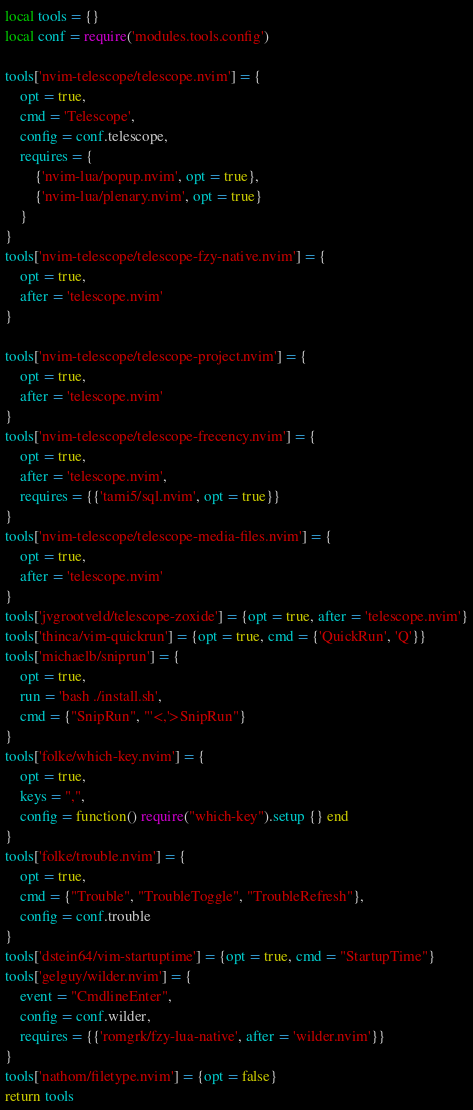<code> <loc_0><loc_0><loc_500><loc_500><_Lua_>local tools = {}
local conf = require('modules.tools.config')

tools['nvim-telescope/telescope.nvim'] = {
    opt = true,
    cmd = 'Telescope',
    config = conf.telescope,
    requires = {
        {'nvim-lua/popup.nvim', opt = true},
        {'nvim-lua/plenary.nvim', opt = true}
    }
}
tools['nvim-telescope/telescope-fzy-native.nvim'] = {
    opt = true,
    after = 'telescope.nvim'
}

tools['nvim-telescope/telescope-project.nvim'] = {
    opt = true,
    after = 'telescope.nvim'
}
tools['nvim-telescope/telescope-frecency.nvim'] = {
    opt = true,
    after = 'telescope.nvim',
    requires = {{'tami5/sql.nvim', opt = true}}
}
tools['nvim-telescope/telescope-media-files.nvim'] = {
    opt = true,
    after = 'telescope.nvim'
}
tools['jvgrootveld/telescope-zoxide'] = {opt = true, after = 'telescope.nvim'}
tools['thinca/vim-quickrun'] = {opt = true, cmd = {'QuickRun', 'Q'}}
tools['michaelb/sniprun'] = {
    opt = true,
    run = 'bash ./install.sh',
    cmd = {"SnipRun", "'<,'>SnipRun"}
}
tools['folke/which-key.nvim'] = {
    opt = true,
    keys = ",",
    config = function() require("which-key").setup {} end
}
tools['folke/trouble.nvim'] = {
    opt = true,
    cmd = {"Trouble", "TroubleToggle", "TroubleRefresh"},
    config = conf.trouble
}
tools['dstein64/vim-startuptime'] = {opt = true, cmd = "StartupTime"}
tools['gelguy/wilder.nvim'] = {
    event = "CmdlineEnter",
    config = conf.wilder,
    requires = {{'romgrk/fzy-lua-native', after = 'wilder.nvim'}}
}
tools['nathom/filetype.nvim'] = {opt = false}
return tools
</code> 